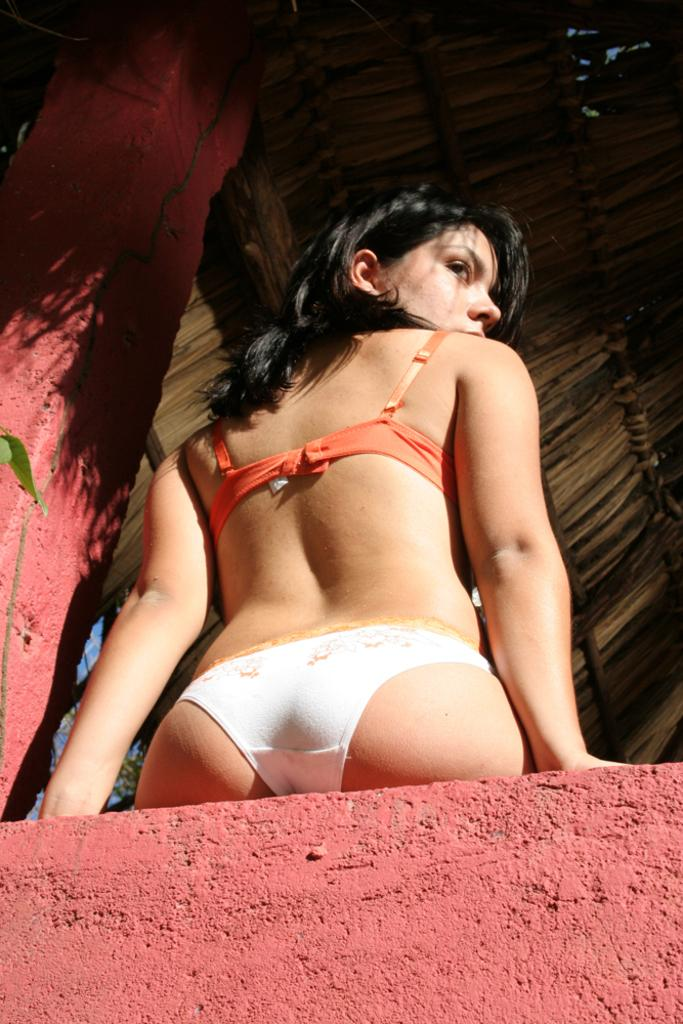Who is present in the image? There is a woman in the image. What architectural feature can be seen in the image? There is a pillar in the image. What type of structure is visible in the image? There is a wall in the image. What type of building is shown in the image? There is a hut in the image. How many brass spiders are crawling on the wall in the image? There are no spiders, let alone brass spiders, present on the wall in the image. 